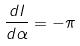Convert formula to latex. <formula><loc_0><loc_0><loc_500><loc_500>\frac { d I } { d \alpha } = - \pi</formula> 